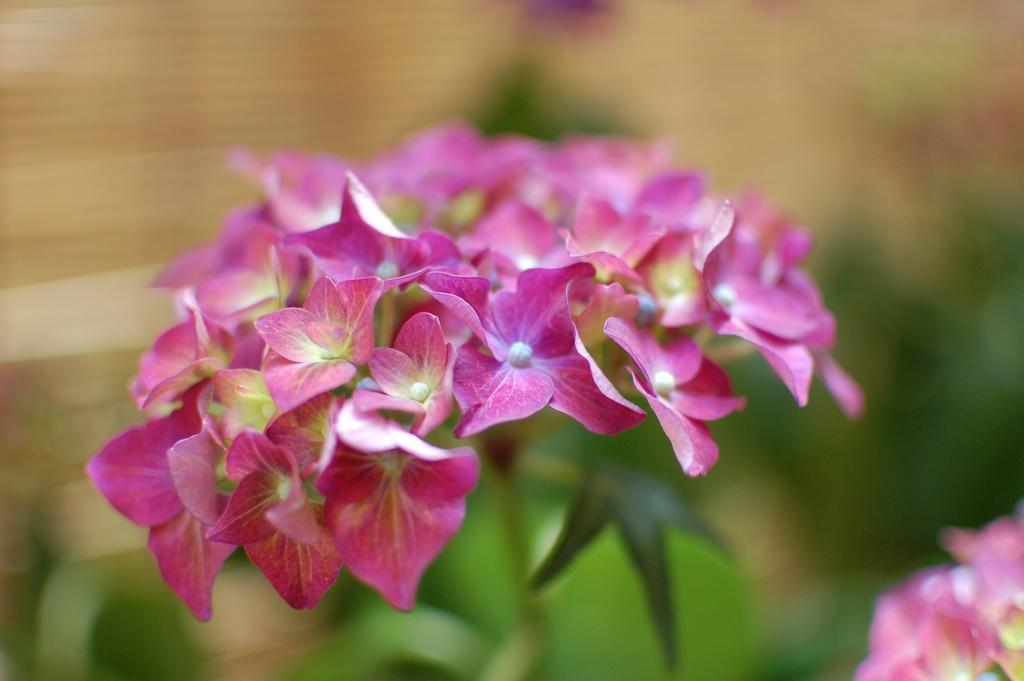What type of flowers can be seen in the image? There are pink color flowers in the image. Can you describe the background of the image? The background of the image is blurred. Is there a snail crawling on the pink flowers in the image? There is no snail present in the image; it only features pink color flowers. What type of cracker is being used to decorate the flowers in the image? There are no crackers present in the image; it only features pink color flowers. 